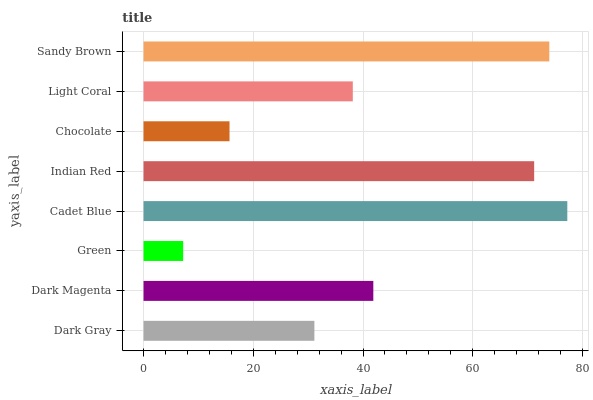Is Green the minimum?
Answer yes or no. Yes. Is Cadet Blue the maximum?
Answer yes or no. Yes. Is Dark Magenta the minimum?
Answer yes or no. No. Is Dark Magenta the maximum?
Answer yes or no. No. Is Dark Magenta greater than Dark Gray?
Answer yes or no. Yes. Is Dark Gray less than Dark Magenta?
Answer yes or no. Yes. Is Dark Gray greater than Dark Magenta?
Answer yes or no. No. Is Dark Magenta less than Dark Gray?
Answer yes or no. No. Is Dark Magenta the high median?
Answer yes or no. Yes. Is Light Coral the low median?
Answer yes or no. Yes. Is Chocolate the high median?
Answer yes or no. No. Is Dark Magenta the low median?
Answer yes or no. No. 